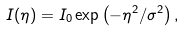Convert formula to latex. <formula><loc_0><loc_0><loc_500><loc_500>I ( \eta ) = I _ { 0 } \exp \left ( - \eta ^ { 2 } / \sigma ^ { 2 } \right ) ,</formula> 